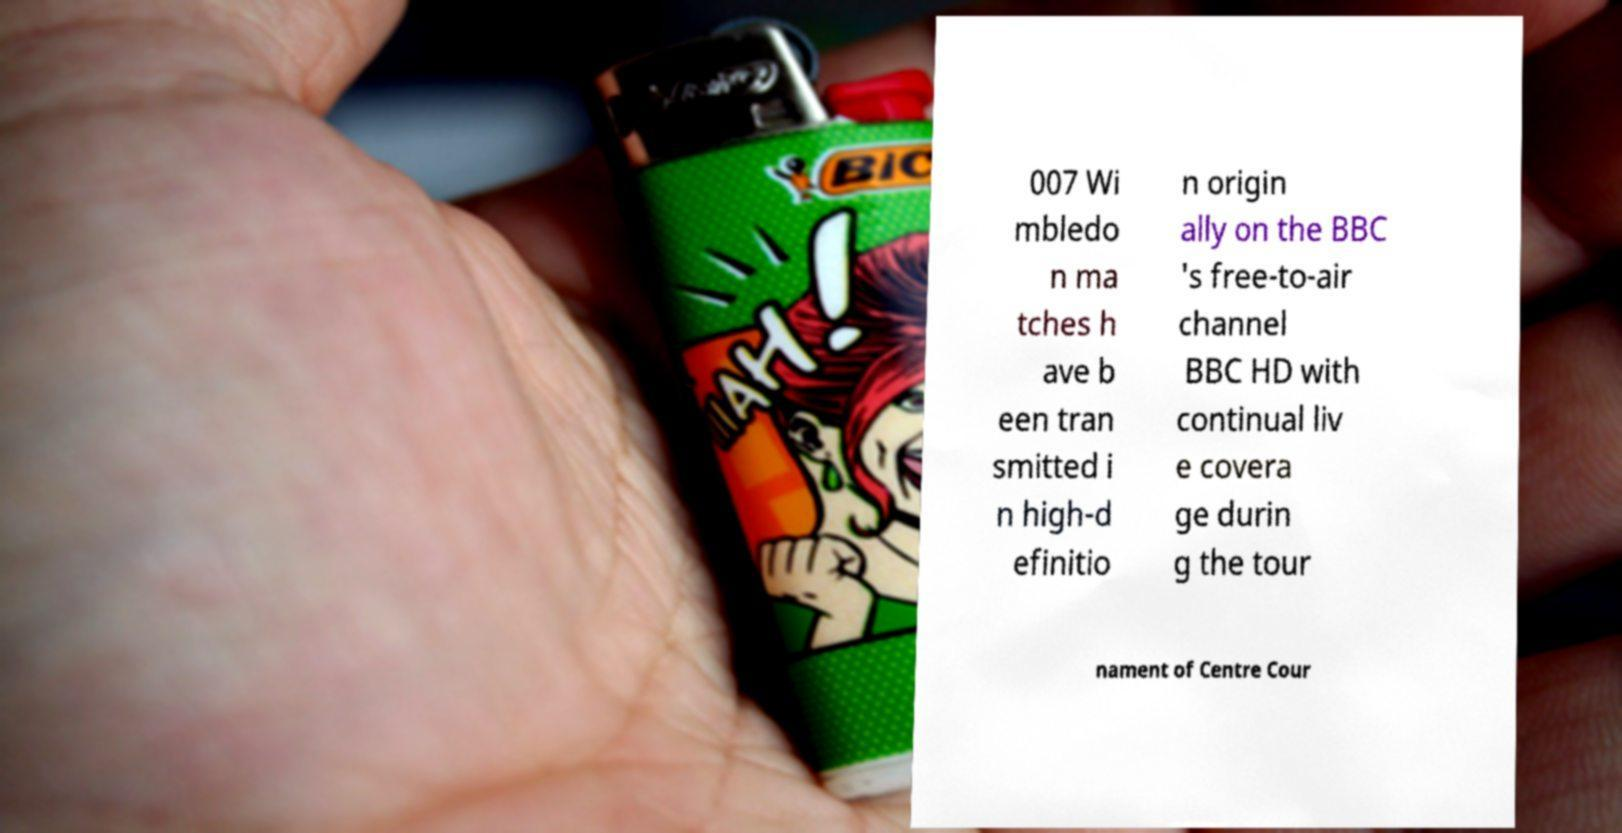I need the written content from this picture converted into text. Can you do that? 007 Wi mbledo n ma tches h ave b een tran smitted i n high-d efinitio n origin ally on the BBC 's free-to-air channel BBC HD with continual liv e covera ge durin g the tour nament of Centre Cour 